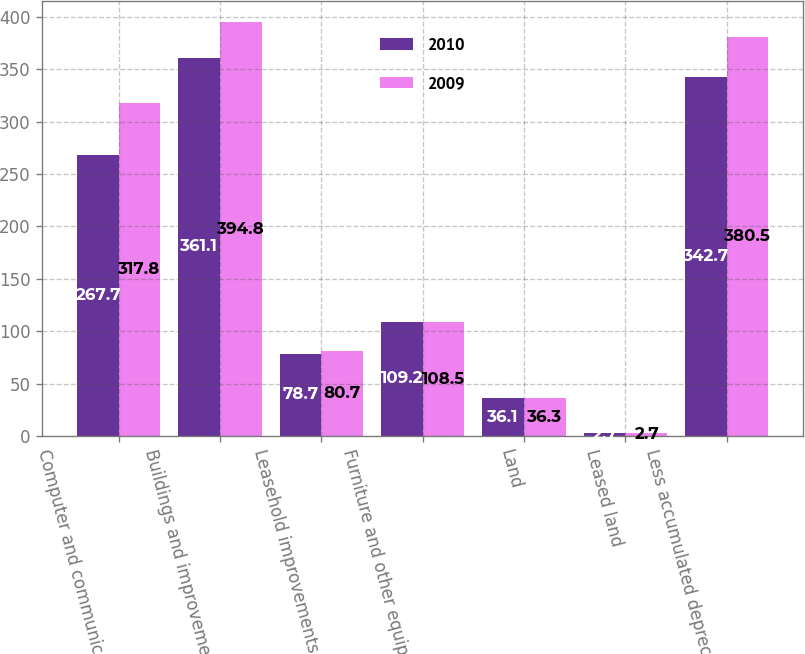<chart> <loc_0><loc_0><loc_500><loc_500><stacked_bar_chart><ecel><fcel>Computer and communications<fcel>Buildings and improvements<fcel>Leasehold improvements<fcel>Furniture and other equipment<fcel>Land<fcel>Leased land<fcel>Less accumulated depreciation<nl><fcel>2010<fcel>267.7<fcel>361.1<fcel>78.7<fcel>109.2<fcel>36.1<fcel>2.7<fcel>342.7<nl><fcel>2009<fcel>317.8<fcel>394.8<fcel>80.7<fcel>108.5<fcel>36.3<fcel>2.7<fcel>380.5<nl></chart> 